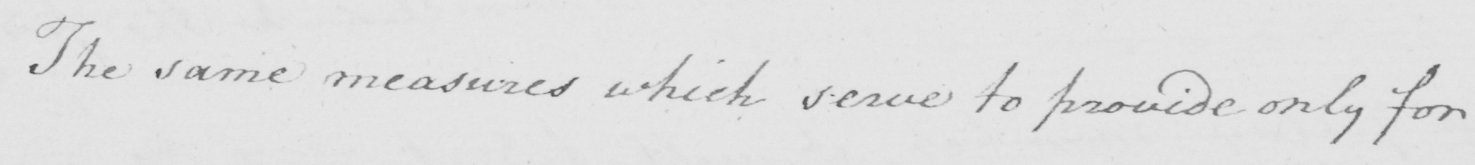Transcribe the text shown in this historical manuscript line. The same measures which serve to provide only for 